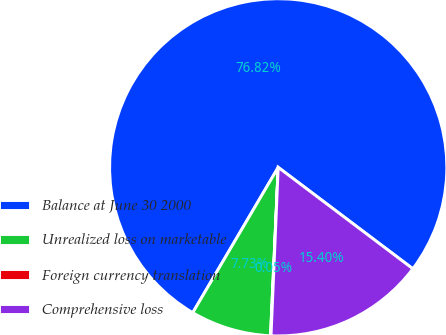Convert chart. <chart><loc_0><loc_0><loc_500><loc_500><pie_chart><fcel>Balance at June 30 2000<fcel>Unrealized loss on marketable<fcel>Foreign currency translation<fcel>Comprehensive loss<nl><fcel>76.81%<fcel>7.73%<fcel>0.05%<fcel>15.4%<nl></chart> 